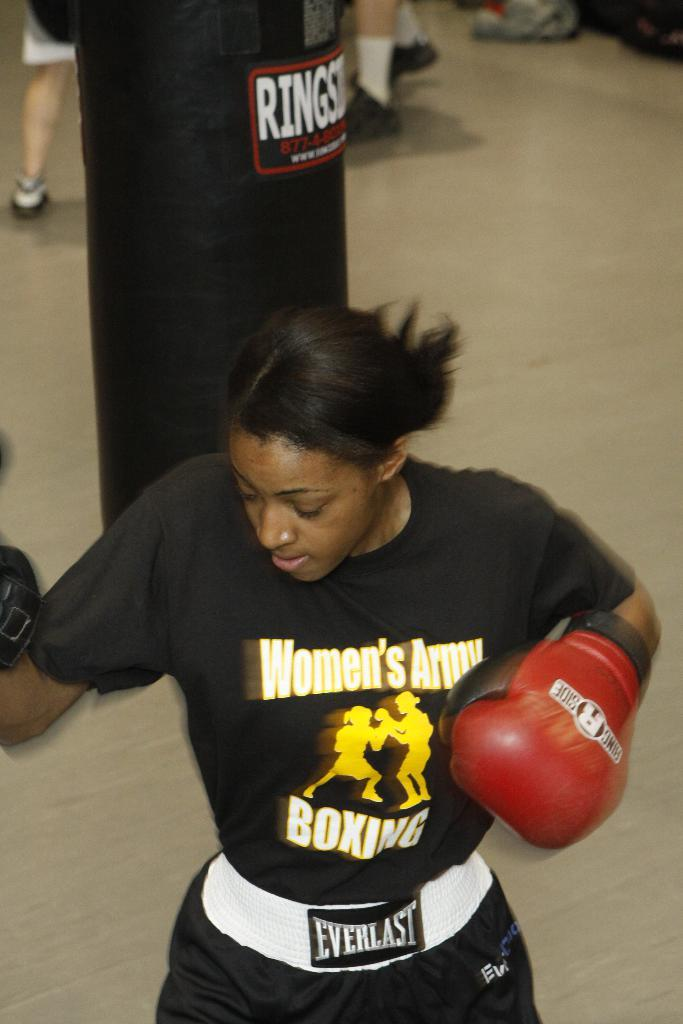<image>
Describe the image concisely. A boxer is wearing a shirt that says, "Women's Army Boxing" in white letters. 